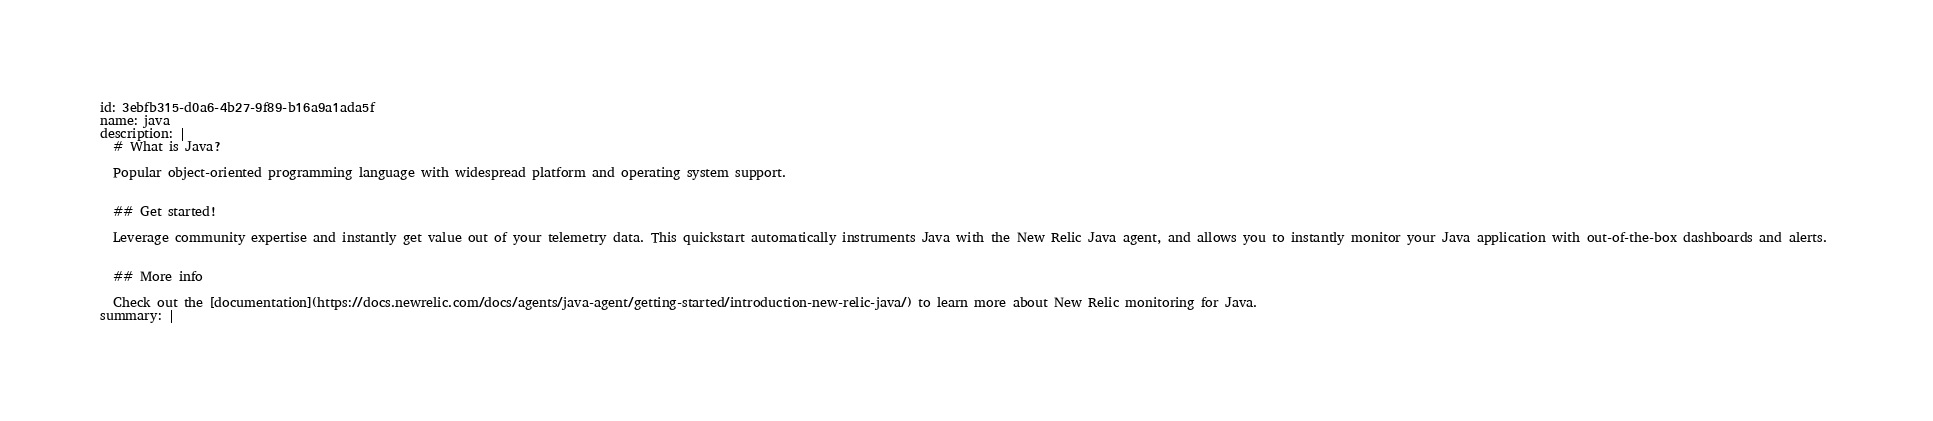<code> <loc_0><loc_0><loc_500><loc_500><_YAML_>id: 3ebfb315-d0a6-4b27-9f89-b16a9a1ada5f
name: java
description: |
  # What is Java?

  Popular object-oriented programming language with widespread platform and operating system support.


  ## Get started!

  Leverage community expertise and instantly get value out of your telemetry data. This quickstart automatically instruments Java with the New Relic Java agent, and allows you to instantly monitor your Java application with out-of-the-box dashboards and alerts. 


  ## More info

  Check out the [documentation](https://docs.newrelic.com/docs/agents/java-agent/getting-started/introduction-new-relic-java/) to learn more about New Relic monitoring for Java.
summary: |</code> 